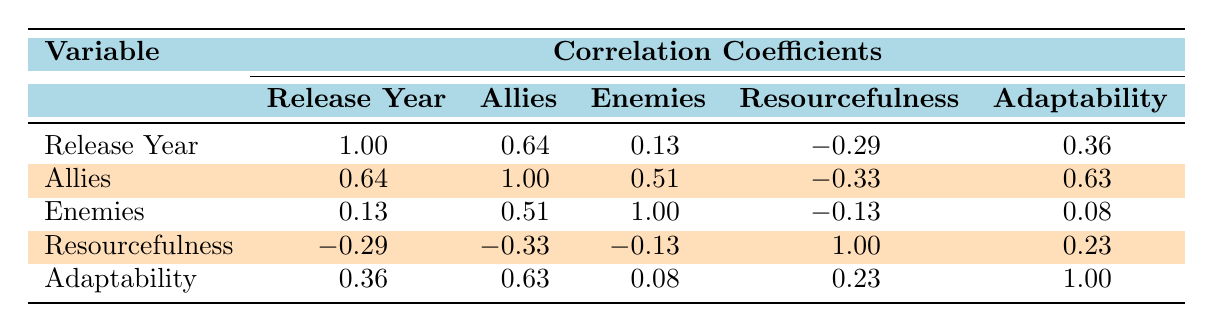What is the correlation between release year and number of allies? The correlation coefficient between release year and number of allies is 0.64. This indicates a moderate positive relationship, meaning that as the release year increases, the number of allies tends to increase as well.
Answer: 0.64 Which female lead character has the highest resourcefulness score? The highest resourcefulness score in the table belongs to Furiosa from "Mad Max: Fury Road," with a score of 10.
Answer: 10 What is the average adaptability score of the films listed? To find the average adaptability score, we sum the adaptability scores (8 + 9 + 8 + 7 + 8 + 9 = 49) and divide by the number of films (6). Thus, the average adaptability score is 49/6 = approximately 8.17.
Answer: 8.17 Is there a higher correlation between the number of allies and adaptability or the number of enemies and resourcefulness? The correlation between allies and adaptability is 0.63, while the correlation between enemies and resourcefulness is -0.13. Since 0.63 is greater than -0.13, there is a higher correlation between the number of allies and adaptability.
Answer: Yes Which film features the lead character with the most enemies? "Resident Evil," featuring Alice, has the highest number of enemies at 4.
Answer: 4 What is the difference in resourcefulness scores between "The Terminator" and "Divergent"? "The Terminator" has a resourcefulness score of 9, while "Divergent" has a score of 7. The difference is 9 - 7 = 2.
Answer: 2 How many films have an adaptability score of 8 or higher? By checking the adaptability scores, we see that "The Terminator," "Terminator 2: Judgment Day," "A Quiet Place," and "Divergent" each have scores of 8 or higher, totaling 4 films.
Answer: 4 If Alice from "Resident Evil" increased her resourcefulness score by 2, would her score be higher than that of Sarah Connor in "Terminator 2: Judgment Day"? Alice's current resourcefulness score is 8. If she increases it by 2, her new score would be 10. Sarah Connor in "Terminator 2: Judgment Day" has a score of 9. Since 10 is greater than 9, Alice would indeed have a higher score.
Answer: Yes 